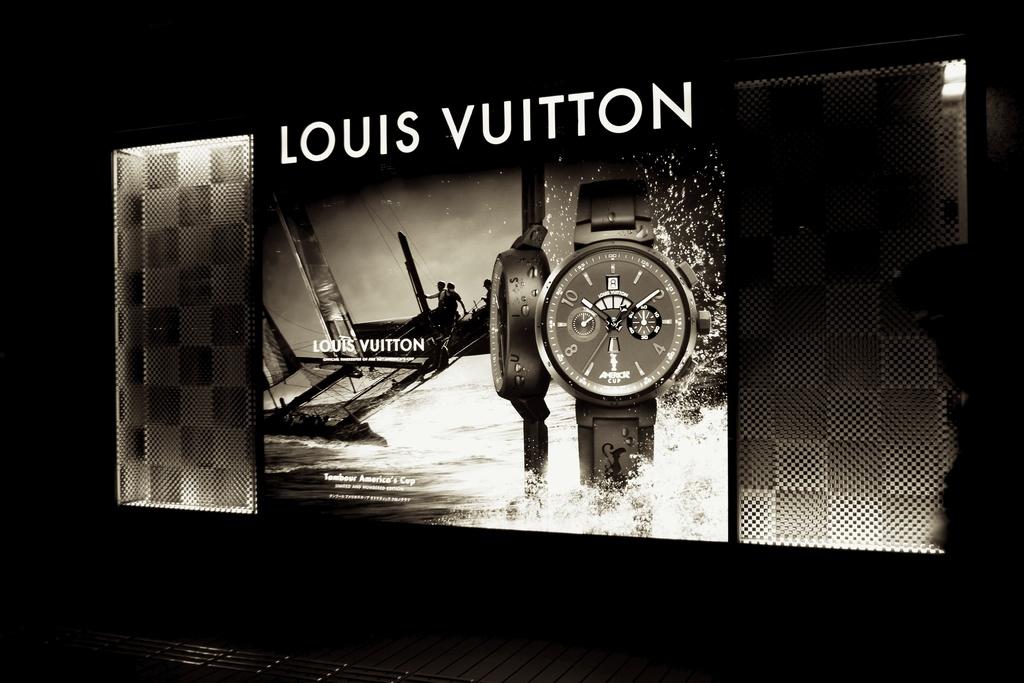What is the name of the brand?
Make the answer very short. Louis vuitton. What's the first letter of the first name?
Offer a terse response. L. 